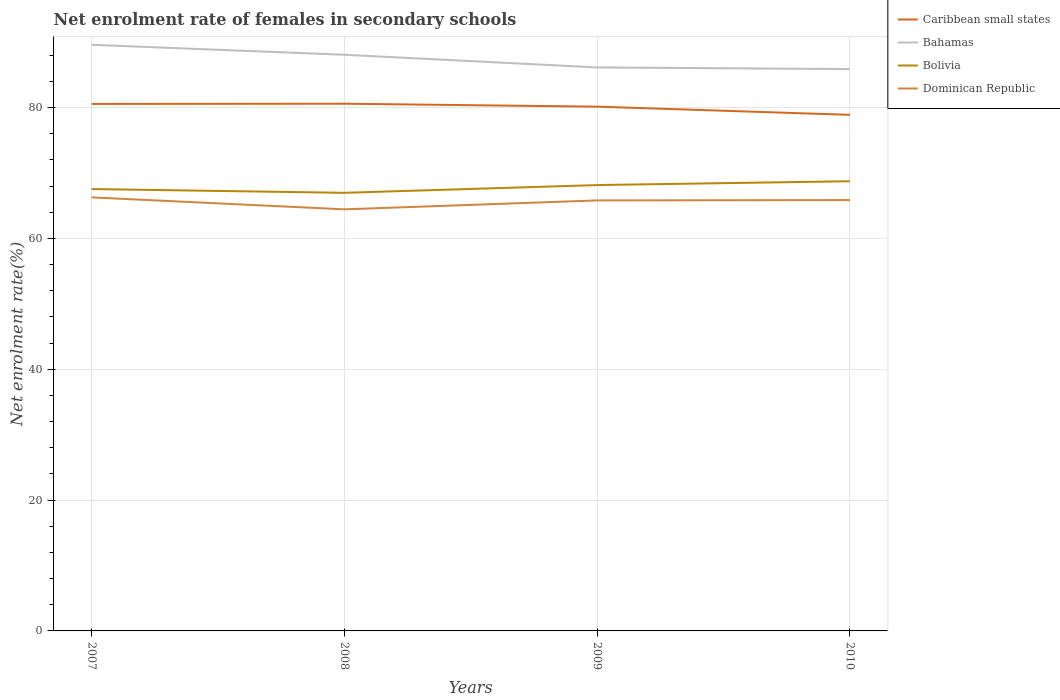Does the line corresponding to Caribbean small states intersect with the line corresponding to Dominican Republic?
Your answer should be compact. No. Is the number of lines equal to the number of legend labels?
Give a very brief answer. Yes. Across all years, what is the maximum net enrolment rate of females in secondary schools in Bolivia?
Your answer should be compact. 66.97. What is the total net enrolment rate of females in secondary schools in Bahamas in the graph?
Keep it short and to the point. 1.52. What is the difference between the highest and the second highest net enrolment rate of females in secondary schools in Bahamas?
Provide a short and direct response. 3.71. What is the difference between the highest and the lowest net enrolment rate of females in secondary schools in Caribbean small states?
Offer a very short reply. 3. Is the net enrolment rate of females in secondary schools in Bahamas strictly greater than the net enrolment rate of females in secondary schools in Caribbean small states over the years?
Keep it short and to the point. No. How many lines are there?
Keep it short and to the point. 4. Are the values on the major ticks of Y-axis written in scientific E-notation?
Make the answer very short. No. How are the legend labels stacked?
Your response must be concise. Vertical. What is the title of the graph?
Offer a terse response. Net enrolment rate of females in secondary schools. What is the label or title of the X-axis?
Keep it short and to the point. Years. What is the label or title of the Y-axis?
Make the answer very short. Net enrolment rate(%). What is the Net enrolment rate(%) of Caribbean small states in 2007?
Your answer should be very brief. 80.56. What is the Net enrolment rate(%) of Bahamas in 2007?
Your answer should be compact. 89.6. What is the Net enrolment rate(%) of Bolivia in 2007?
Give a very brief answer. 67.55. What is the Net enrolment rate(%) in Dominican Republic in 2007?
Your answer should be very brief. 66.27. What is the Net enrolment rate(%) in Caribbean small states in 2008?
Offer a terse response. 80.6. What is the Net enrolment rate(%) in Bahamas in 2008?
Provide a short and direct response. 88.08. What is the Net enrolment rate(%) in Bolivia in 2008?
Your answer should be very brief. 66.97. What is the Net enrolment rate(%) of Dominican Republic in 2008?
Make the answer very short. 64.45. What is the Net enrolment rate(%) in Caribbean small states in 2009?
Give a very brief answer. 80.14. What is the Net enrolment rate(%) of Bahamas in 2009?
Offer a terse response. 86.14. What is the Net enrolment rate(%) in Bolivia in 2009?
Give a very brief answer. 68.16. What is the Net enrolment rate(%) in Dominican Republic in 2009?
Your answer should be compact. 65.81. What is the Net enrolment rate(%) of Caribbean small states in 2010?
Make the answer very short. 78.89. What is the Net enrolment rate(%) of Bahamas in 2010?
Ensure brevity in your answer.  85.89. What is the Net enrolment rate(%) of Bolivia in 2010?
Your answer should be compact. 68.74. What is the Net enrolment rate(%) of Dominican Republic in 2010?
Your response must be concise. 65.86. Across all years, what is the maximum Net enrolment rate(%) of Caribbean small states?
Give a very brief answer. 80.6. Across all years, what is the maximum Net enrolment rate(%) of Bahamas?
Your answer should be very brief. 89.6. Across all years, what is the maximum Net enrolment rate(%) of Bolivia?
Ensure brevity in your answer.  68.74. Across all years, what is the maximum Net enrolment rate(%) of Dominican Republic?
Give a very brief answer. 66.27. Across all years, what is the minimum Net enrolment rate(%) of Caribbean small states?
Keep it short and to the point. 78.89. Across all years, what is the minimum Net enrolment rate(%) of Bahamas?
Your answer should be compact. 85.89. Across all years, what is the minimum Net enrolment rate(%) in Bolivia?
Keep it short and to the point. 66.97. Across all years, what is the minimum Net enrolment rate(%) in Dominican Republic?
Your response must be concise. 64.45. What is the total Net enrolment rate(%) in Caribbean small states in the graph?
Make the answer very short. 320.2. What is the total Net enrolment rate(%) in Bahamas in the graph?
Your response must be concise. 349.71. What is the total Net enrolment rate(%) of Bolivia in the graph?
Keep it short and to the point. 271.43. What is the total Net enrolment rate(%) of Dominican Republic in the graph?
Keep it short and to the point. 262.4. What is the difference between the Net enrolment rate(%) of Caribbean small states in 2007 and that in 2008?
Your response must be concise. -0.03. What is the difference between the Net enrolment rate(%) of Bahamas in 2007 and that in 2008?
Offer a terse response. 1.52. What is the difference between the Net enrolment rate(%) of Bolivia in 2007 and that in 2008?
Your response must be concise. 0.58. What is the difference between the Net enrolment rate(%) of Dominican Republic in 2007 and that in 2008?
Your answer should be very brief. 1.83. What is the difference between the Net enrolment rate(%) of Caribbean small states in 2007 and that in 2009?
Offer a terse response. 0.42. What is the difference between the Net enrolment rate(%) in Bahamas in 2007 and that in 2009?
Offer a very short reply. 3.46. What is the difference between the Net enrolment rate(%) in Bolivia in 2007 and that in 2009?
Ensure brevity in your answer.  -0.61. What is the difference between the Net enrolment rate(%) of Dominican Republic in 2007 and that in 2009?
Provide a succinct answer. 0.46. What is the difference between the Net enrolment rate(%) of Caribbean small states in 2007 and that in 2010?
Your response must be concise. 1.67. What is the difference between the Net enrolment rate(%) of Bahamas in 2007 and that in 2010?
Give a very brief answer. 3.71. What is the difference between the Net enrolment rate(%) in Bolivia in 2007 and that in 2010?
Ensure brevity in your answer.  -1.19. What is the difference between the Net enrolment rate(%) of Dominican Republic in 2007 and that in 2010?
Offer a very short reply. 0.41. What is the difference between the Net enrolment rate(%) of Caribbean small states in 2008 and that in 2009?
Provide a short and direct response. 0.45. What is the difference between the Net enrolment rate(%) of Bahamas in 2008 and that in 2009?
Offer a very short reply. 1.93. What is the difference between the Net enrolment rate(%) in Bolivia in 2008 and that in 2009?
Make the answer very short. -1.18. What is the difference between the Net enrolment rate(%) in Dominican Republic in 2008 and that in 2009?
Offer a very short reply. -1.37. What is the difference between the Net enrolment rate(%) in Caribbean small states in 2008 and that in 2010?
Your answer should be compact. 1.7. What is the difference between the Net enrolment rate(%) in Bahamas in 2008 and that in 2010?
Offer a terse response. 2.19. What is the difference between the Net enrolment rate(%) of Bolivia in 2008 and that in 2010?
Provide a short and direct response. -1.77. What is the difference between the Net enrolment rate(%) in Dominican Republic in 2008 and that in 2010?
Ensure brevity in your answer.  -1.41. What is the difference between the Net enrolment rate(%) in Caribbean small states in 2009 and that in 2010?
Offer a terse response. 1.25. What is the difference between the Net enrolment rate(%) in Bahamas in 2009 and that in 2010?
Keep it short and to the point. 0.26. What is the difference between the Net enrolment rate(%) of Bolivia in 2009 and that in 2010?
Give a very brief answer. -0.59. What is the difference between the Net enrolment rate(%) in Dominican Republic in 2009 and that in 2010?
Make the answer very short. -0.05. What is the difference between the Net enrolment rate(%) in Caribbean small states in 2007 and the Net enrolment rate(%) in Bahamas in 2008?
Ensure brevity in your answer.  -7.51. What is the difference between the Net enrolment rate(%) in Caribbean small states in 2007 and the Net enrolment rate(%) in Bolivia in 2008?
Offer a very short reply. 13.59. What is the difference between the Net enrolment rate(%) of Caribbean small states in 2007 and the Net enrolment rate(%) of Dominican Republic in 2008?
Your response must be concise. 16.12. What is the difference between the Net enrolment rate(%) of Bahamas in 2007 and the Net enrolment rate(%) of Bolivia in 2008?
Make the answer very short. 22.63. What is the difference between the Net enrolment rate(%) in Bahamas in 2007 and the Net enrolment rate(%) in Dominican Republic in 2008?
Offer a very short reply. 25.15. What is the difference between the Net enrolment rate(%) of Bolivia in 2007 and the Net enrolment rate(%) of Dominican Republic in 2008?
Keep it short and to the point. 3.1. What is the difference between the Net enrolment rate(%) of Caribbean small states in 2007 and the Net enrolment rate(%) of Bahamas in 2009?
Keep it short and to the point. -5.58. What is the difference between the Net enrolment rate(%) of Caribbean small states in 2007 and the Net enrolment rate(%) of Bolivia in 2009?
Offer a very short reply. 12.41. What is the difference between the Net enrolment rate(%) of Caribbean small states in 2007 and the Net enrolment rate(%) of Dominican Republic in 2009?
Provide a short and direct response. 14.75. What is the difference between the Net enrolment rate(%) in Bahamas in 2007 and the Net enrolment rate(%) in Bolivia in 2009?
Offer a terse response. 21.44. What is the difference between the Net enrolment rate(%) in Bahamas in 2007 and the Net enrolment rate(%) in Dominican Republic in 2009?
Provide a short and direct response. 23.79. What is the difference between the Net enrolment rate(%) in Bolivia in 2007 and the Net enrolment rate(%) in Dominican Republic in 2009?
Provide a short and direct response. 1.74. What is the difference between the Net enrolment rate(%) in Caribbean small states in 2007 and the Net enrolment rate(%) in Bahamas in 2010?
Provide a short and direct response. -5.32. What is the difference between the Net enrolment rate(%) in Caribbean small states in 2007 and the Net enrolment rate(%) in Bolivia in 2010?
Your answer should be very brief. 11.82. What is the difference between the Net enrolment rate(%) of Caribbean small states in 2007 and the Net enrolment rate(%) of Dominican Republic in 2010?
Ensure brevity in your answer.  14.7. What is the difference between the Net enrolment rate(%) in Bahamas in 2007 and the Net enrolment rate(%) in Bolivia in 2010?
Make the answer very short. 20.86. What is the difference between the Net enrolment rate(%) in Bahamas in 2007 and the Net enrolment rate(%) in Dominican Republic in 2010?
Give a very brief answer. 23.74. What is the difference between the Net enrolment rate(%) of Bolivia in 2007 and the Net enrolment rate(%) of Dominican Republic in 2010?
Your answer should be compact. 1.69. What is the difference between the Net enrolment rate(%) of Caribbean small states in 2008 and the Net enrolment rate(%) of Bahamas in 2009?
Your answer should be compact. -5.55. What is the difference between the Net enrolment rate(%) in Caribbean small states in 2008 and the Net enrolment rate(%) in Bolivia in 2009?
Your answer should be very brief. 12.44. What is the difference between the Net enrolment rate(%) of Caribbean small states in 2008 and the Net enrolment rate(%) of Dominican Republic in 2009?
Your answer should be compact. 14.78. What is the difference between the Net enrolment rate(%) in Bahamas in 2008 and the Net enrolment rate(%) in Bolivia in 2009?
Keep it short and to the point. 19.92. What is the difference between the Net enrolment rate(%) of Bahamas in 2008 and the Net enrolment rate(%) of Dominican Republic in 2009?
Keep it short and to the point. 22.26. What is the difference between the Net enrolment rate(%) of Bolivia in 2008 and the Net enrolment rate(%) of Dominican Republic in 2009?
Provide a short and direct response. 1.16. What is the difference between the Net enrolment rate(%) of Caribbean small states in 2008 and the Net enrolment rate(%) of Bahamas in 2010?
Give a very brief answer. -5.29. What is the difference between the Net enrolment rate(%) in Caribbean small states in 2008 and the Net enrolment rate(%) in Bolivia in 2010?
Offer a very short reply. 11.85. What is the difference between the Net enrolment rate(%) in Caribbean small states in 2008 and the Net enrolment rate(%) in Dominican Republic in 2010?
Offer a terse response. 14.73. What is the difference between the Net enrolment rate(%) in Bahamas in 2008 and the Net enrolment rate(%) in Bolivia in 2010?
Your answer should be compact. 19.33. What is the difference between the Net enrolment rate(%) in Bahamas in 2008 and the Net enrolment rate(%) in Dominican Republic in 2010?
Your answer should be very brief. 22.22. What is the difference between the Net enrolment rate(%) in Bolivia in 2008 and the Net enrolment rate(%) in Dominican Republic in 2010?
Give a very brief answer. 1.11. What is the difference between the Net enrolment rate(%) in Caribbean small states in 2009 and the Net enrolment rate(%) in Bahamas in 2010?
Provide a short and direct response. -5.74. What is the difference between the Net enrolment rate(%) in Caribbean small states in 2009 and the Net enrolment rate(%) in Bolivia in 2010?
Your response must be concise. 11.4. What is the difference between the Net enrolment rate(%) of Caribbean small states in 2009 and the Net enrolment rate(%) of Dominican Republic in 2010?
Offer a terse response. 14.28. What is the difference between the Net enrolment rate(%) of Bahamas in 2009 and the Net enrolment rate(%) of Bolivia in 2010?
Your answer should be very brief. 17.4. What is the difference between the Net enrolment rate(%) in Bahamas in 2009 and the Net enrolment rate(%) in Dominican Republic in 2010?
Your answer should be compact. 20.28. What is the difference between the Net enrolment rate(%) in Bolivia in 2009 and the Net enrolment rate(%) in Dominican Republic in 2010?
Provide a short and direct response. 2.3. What is the average Net enrolment rate(%) in Caribbean small states per year?
Provide a succinct answer. 80.05. What is the average Net enrolment rate(%) of Bahamas per year?
Offer a very short reply. 87.43. What is the average Net enrolment rate(%) of Bolivia per year?
Offer a terse response. 67.86. What is the average Net enrolment rate(%) in Dominican Republic per year?
Offer a terse response. 65.6. In the year 2007, what is the difference between the Net enrolment rate(%) of Caribbean small states and Net enrolment rate(%) of Bahamas?
Ensure brevity in your answer.  -9.04. In the year 2007, what is the difference between the Net enrolment rate(%) of Caribbean small states and Net enrolment rate(%) of Bolivia?
Ensure brevity in your answer.  13.01. In the year 2007, what is the difference between the Net enrolment rate(%) of Caribbean small states and Net enrolment rate(%) of Dominican Republic?
Provide a succinct answer. 14.29. In the year 2007, what is the difference between the Net enrolment rate(%) in Bahamas and Net enrolment rate(%) in Bolivia?
Offer a very short reply. 22.05. In the year 2007, what is the difference between the Net enrolment rate(%) in Bahamas and Net enrolment rate(%) in Dominican Republic?
Ensure brevity in your answer.  23.33. In the year 2007, what is the difference between the Net enrolment rate(%) in Bolivia and Net enrolment rate(%) in Dominican Republic?
Offer a terse response. 1.28. In the year 2008, what is the difference between the Net enrolment rate(%) in Caribbean small states and Net enrolment rate(%) in Bahamas?
Ensure brevity in your answer.  -7.48. In the year 2008, what is the difference between the Net enrolment rate(%) of Caribbean small states and Net enrolment rate(%) of Bolivia?
Keep it short and to the point. 13.62. In the year 2008, what is the difference between the Net enrolment rate(%) in Caribbean small states and Net enrolment rate(%) in Dominican Republic?
Offer a terse response. 16.15. In the year 2008, what is the difference between the Net enrolment rate(%) of Bahamas and Net enrolment rate(%) of Bolivia?
Offer a very short reply. 21.1. In the year 2008, what is the difference between the Net enrolment rate(%) of Bahamas and Net enrolment rate(%) of Dominican Republic?
Provide a short and direct response. 23.63. In the year 2008, what is the difference between the Net enrolment rate(%) of Bolivia and Net enrolment rate(%) of Dominican Republic?
Provide a short and direct response. 2.53. In the year 2009, what is the difference between the Net enrolment rate(%) in Caribbean small states and Net enrolment rate(%) in Bahamas?
Your answer should be very brief. -6. In the year 2009, what is the difference between the Net enrolment rate(%) in Caribbean small states and Net enrolment rate(%) in Bolivia?
Give a very brief answer. 11.99. In the year 2009, what is the difference between the Net enrolment rate(%) of Caribbean small states and Net enrolment rate(%) of Dominican Republic?
Your answer should be very brief. 14.33. In the year 2009, what is the difference between the Net enrolment rate(%) of Bahamas and Net enrolment rate(%) of Bolivia?
Give a very brief answer. 17.99. In the year 2009, what is the difference between the Net enrolment rate(%) in Bahamas and Net enrolment rate(%) in Dominican Republic?
Your answer should be compact. 20.33. In the year 2009, what is the difference between the Net enrolment rate(%) of Bolivia and Net enrolment rate(%) of Dominican Republic?
Give a very brief answer. 2.34. In the year 2010, what is the difference between the Net enrolment rate(%) in Caribbean small states and Net enrolment rate(%) in Bahamas?
Make the answer very short. -6.99. In the year 2010, what is the difference between the Net enrolment rate(%) in Caribbean small states and Net enrolment rate(%) in Bolivia?
Your response must be concise. 10.15. In the year 2010, what is the difference between the Net enrolment rate(%) of Caribbean small states and Net enrolment rate(%) of Dominican Republic?
Offer a very short reply. 13.03. In the year 2010, what is the difference between the Net enrolment rate(%) in Bahamas and Net enrolment rate(%) in Bolivia?
Ensure brevity in your answer.  17.14. In the year 2010, what is the difference between the Net enrolment rate(%) of Bahamas and Net enrolment rate(%) of Dominican Republic?
Give a very brief answer. 20.03. In the year 2010, what is the difference between the Net enrolment rate(%) of Bolivia and Net enrolment rate(%) of Dominican Republic?
Make the answer very short. 2.88. What is the ratio of the Net enrolment rate(%) in Bahamas in 2007 to that in 2008?
Provide a short and direct response. 1.02. What is the ratio of the Net enrolment rate(%) of Bolivia in 2007 to that in 2008?
Offer a terse response. 1.01. What is the ratio of the Net enrolment rate(%) in Dominican Republic in 2007 to that in 2008?
Offer a terse response. 1.03. What is the ratio of the Net enrolment rate(%) of Caribbean small states in 2007 to that in 2009?
Provide a short and direct response. 1.01. What is the ratio of the Net enrolment rate(%) in Bahamas in 2007 to that in 2009?
Offer a terse response. 1.04. What is the ratio of the Net enrolment rate(%) in Dominican Republic in 2007 to that in 2009?
Offer a terse response. 1.01. What is the ratio of the Net enrolment rate(%) in Caribbean small states in 2007 to that in 2010?
Keep it short and to the point. 1.02. What is the ratio of the Net enrolment rate(%) of Bahamas in 2007 to that in 2010?
Provide a succinct answer. 1.04. What is the ratio of the Net enrolment rate(%) in Bolivia in 2007 to that in 2010?
Provide a succinct answer. 0.98. What is the ratio of the Net enrolment rate(%) of Caribbean small states in 2008 to that in 2009?
Provide a succinct answer. 1.01. What is the ratio of the Net enrolment rate(%) of Bahamas in 2008 to that in 2009?
Offer a very short reply. 1.02. What is the ratio of the Net enrolment rate(%) in Bolivia in 2008 to that in 2009?
Offer a very short reply. 0.98. What is the ratio of the Net enrolment rate(%) of Dominican Republic in 2008 to that in 2009?
Your answer should be compact. 0.98. What is the ratio of the Net enrolment rate(%) in Caribbean small states in 2008 to that in 2010?
Ensure brevity in your answer.  1.02. What is the ratio of the Net enrolment rate(%) in Bahamas in 2008 to that in 2010?
Provide a succinct answer. 1.03. What is the ratio of the Net enrolment rate(%) in Bolivia in 2008 to that in 2010?
Offer a terse response. 0.97. What is the ratio of the Net enrolment rate(%) in Dominican Republic in 2008 to that in 2010?
Your answer should be very brief. 0.98. What is the ratio of the Net enrolment rate(%) of Caribbean small states in 2009 to that in 2010?
Ensure brevity in your answer.  1.02. What is the difference between the highest and the second highest Net enrolment rate(%) in Caribbean small states?
Your response must be concise. 0.03. What is the difference between the highest and the second highest Net enrolment rate(%) of Bahamas?
Make the answer very short. 1.52. What is the difference between the highest and the second highest Net enrolment rate(%) of Bolivia?
Keep it short and to the point. 0.59. What is the difference between the highest and the second highest Net enrolment rate(%) in Dominican Republic?
Provide a succinct answer. 0.41. What is the difference between the highest and the lowest Net enrolment rate(%) of Caribbean small states?
Make the answer very short. 1.7. What is the difference between the highest and the lowest Net enrolment rate(%) in Bahamas?
Ensure brevity in your answer.  3.71. What is the difference between the highest and the lowest Net enrolment rate(%) of Bolivia?
Keep it short and to the point. 1.77. What is the difference between the highest and the lowest Net enrolment rate(%) of Dominican Republic?
Your answer should be compact. 1.83. 